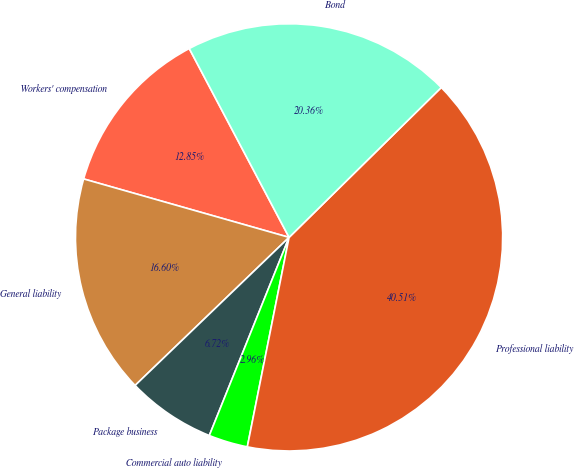Convert chart. <chart><loc_0><loc_0><loc_500><loc_500><pie_chart><fcel>Workers' compensation<fcel>General liability<fcel>Package business<fcel>Commercial auto liability<fcel>Professional liability<fcel>Bond<nl><fcel>12.85%<fcel>16.6%<fcel>6.72%<fcel>2.96%<fcel>40.51%<fcel>20.36%<nl></chart> 